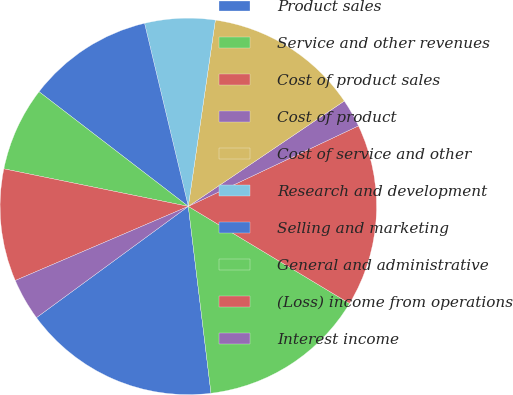<chart> <loc_0><loc_0><loc_500><loc_500><pie_chart><fcel>Product sales<fcel>Service and other revenues<fcel>Cost of product sales<fcel>Cost of product<fcel>Cost of service and other<fcel>Research and development<fcel>Selling and marketing<fcel>General and administrative<fcel>(Loss) income from operations<fcel>Interest income<nl><fcel>16.86%<fcel>14.45%<fcel>15.66%<fcel>2.42%<fcel>13.25%<fcel>6.03%<fcel>10.84%<fcel>7.23%<fcel>9.64%<fcel>3.62%<nl></chart> 